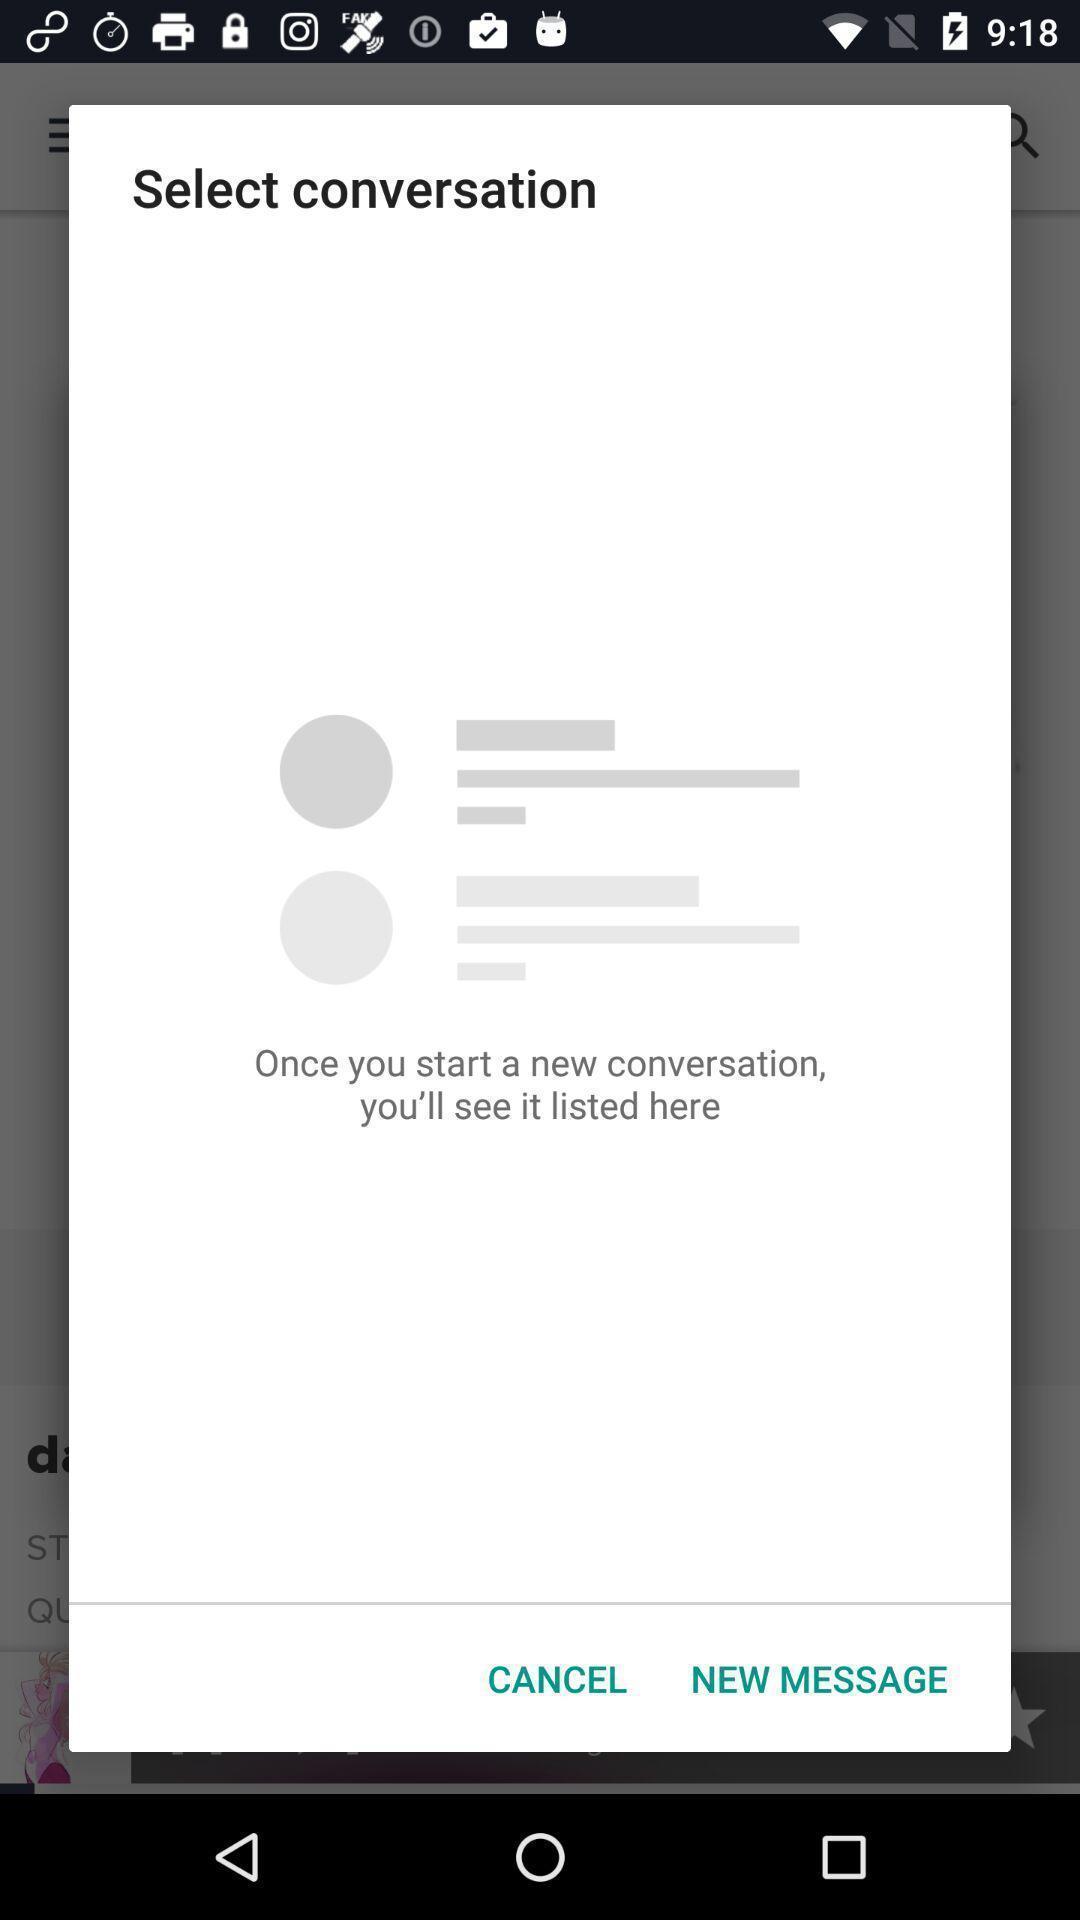What details can you identify in this image? Popup showing for new conversation. 